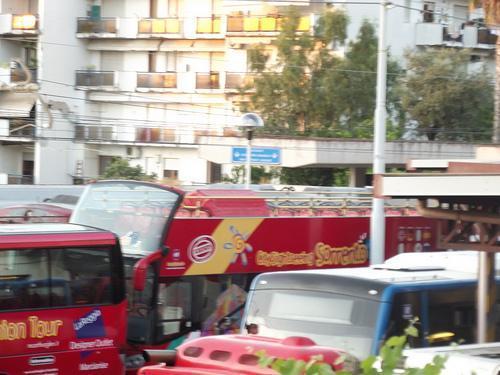How many blue signs are there?
Give a very brief answer. 1. 